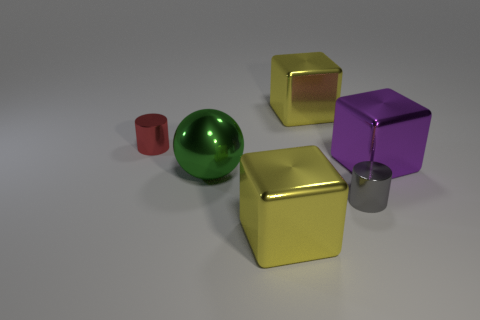How many objects are there in total, and can you describe their colors? There are five objects in total: a red cylinder, a green sphere, two yellow cubes, and a gray cylinder. Do the cubes have different surface finishes? Yes, one of the yellow cubes has a matte finish while the other has a metallic, reflective finish. 